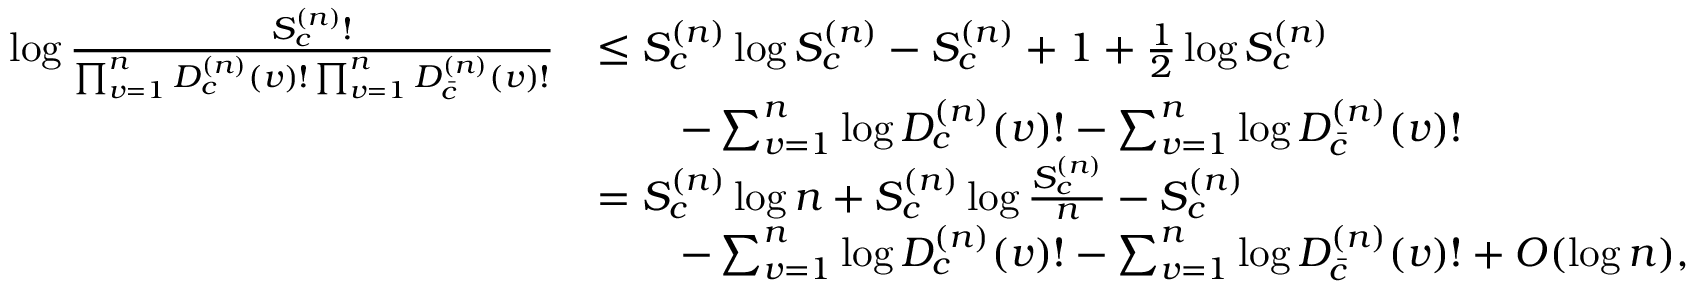Convert formula to latex. <formula><loc_0><loc_0><loc_500><loc_500>\begin{array} { r l } { \log \frac { S _ { c } ^ { ( n ) } ! } { \prod _ { v = 1 } ^ { n } D _ { c } ^ { ( n ) } ( v ) ! \prod _ { v = 1 } ^ { n } D _ { \bar { c } } ^ { ( n ) } ( v ) ! } } & { \leq S _ { c } ^ { ( n ) } \log S _ { c } ^ { ( n ) } - S _ { c } ^ { ( n ) } + 1 + \frac { 1 } { 2 } \log S _ { c } ^ { ( n ) } } \\ & { \quad - \sum _ { v = 1 } ^ { n } \log D _ { c } ^ { ( n ) } ( v ) ! - \sum _ { v = 1 } ^ { n } \log D _ { \bar { c } } ^ { ( n ) } ( v ) ! } \\ & { = S _ { c } ^ { ( n ) } \log n + S _ { c } ^ { ( n ) } \log \frac { S _ { c } ^ { ( n ) } } { n } - S _ { c } ^ { ( n ) } } \\ & { \quad - \sum _ { v = 1 } ^ { n } \log D _ { c } ^ { ( n ) } ( v ) ! - \sum _ { v = 1 } ^ { n } \log D _ { \bar { c } } ^ { ( n ) } ( v ) ! + O ( \log n ) , } \end{array}</formula> 